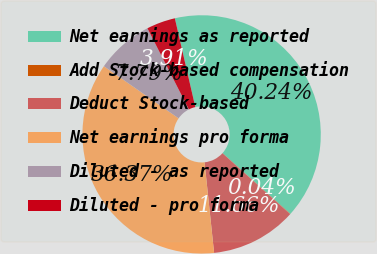<chart> <loc_0><loc_0><loc_500><loc_500><pie_chart><fcel>Net earnings as reported<fcel>Add Stock-based compensation<fcel>Deduct Stock-based<fcel>Net earnings pro forma<fcel>Diluted - as reported<fcel>Diluted - pro forma<nl><fcel>40.24%<fcel>0.04%<fcel>11.66%<fcel>36.37%<fcel>7.79%<fcel>3.91%<nl></chart> 